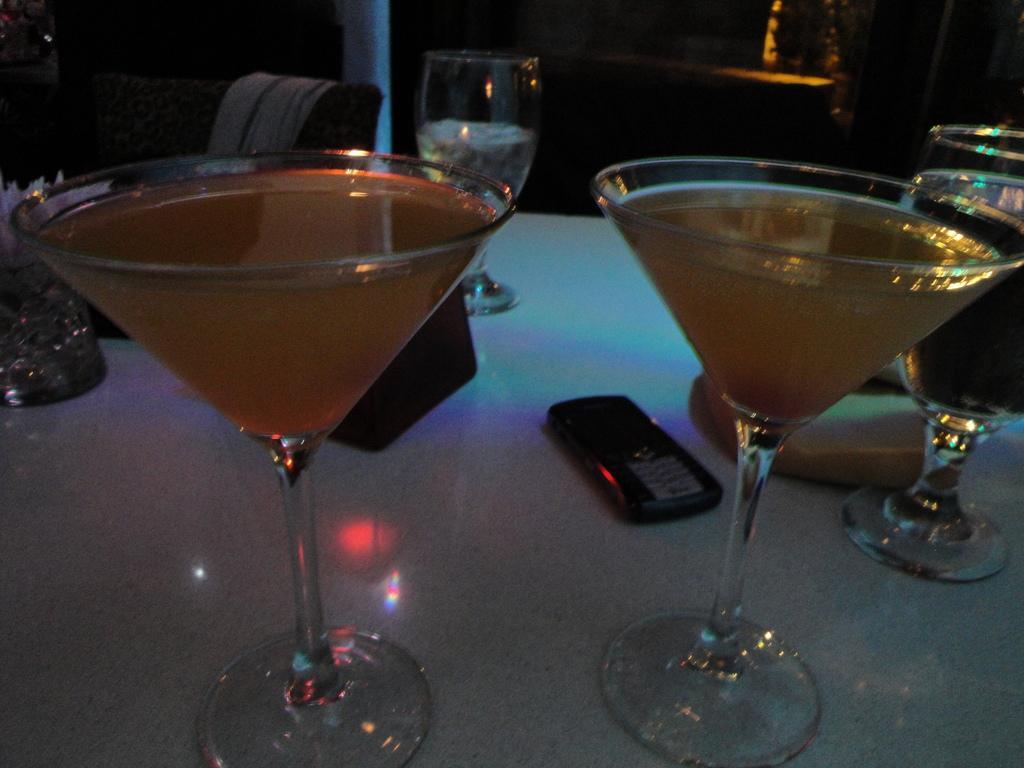Please provide a concise description of this image. There are two glasses filled with drinks arranged on a table, on which there are a mobile, other glasses and other objects. In the background, there is a light. And the background is dark in color. 